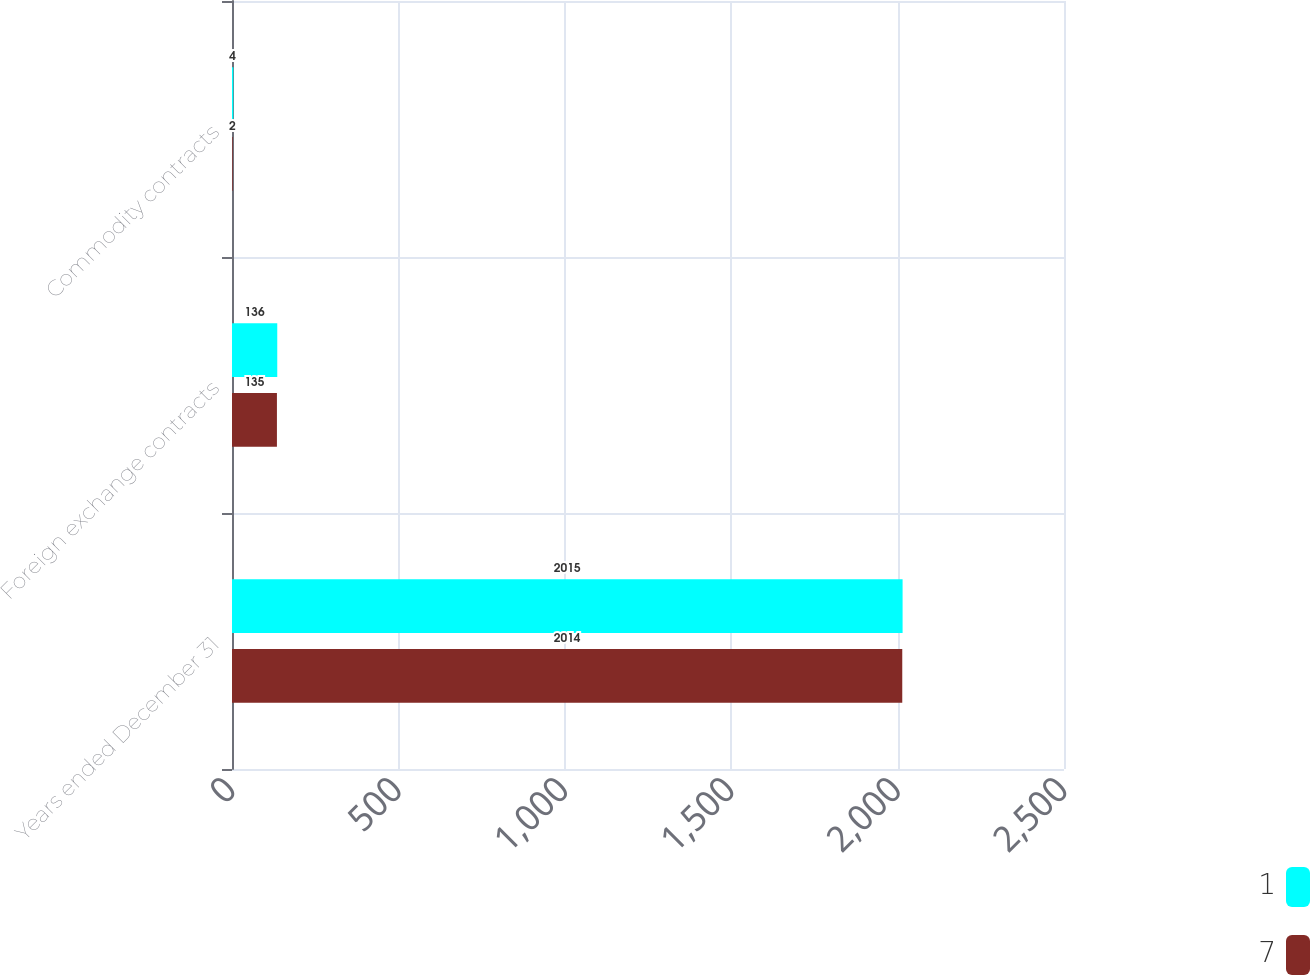Convert chart. <chart><loc_0><loc_0><loc_500><loc_500><stacked_bar_chart><ecel><fcel>Years ended December 31<fcel>Foreign exchange contracts<fcel>Commodity contracts<nl><fcel>1<fcel>2015<fcel>136<fcel>4<nl><fcel>7<fcel>2014<fcel>135<fcel>2<nl></chart> 